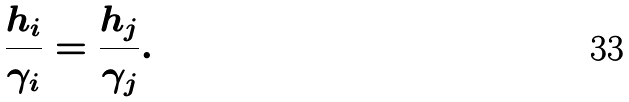<formula> <loc_0><loc_0><loc_500><loc_500>\frac { h _ { i } } { \gamma _ { i } } = \frac { h _ { j } } { \gamma _ { j } } .</formula> 